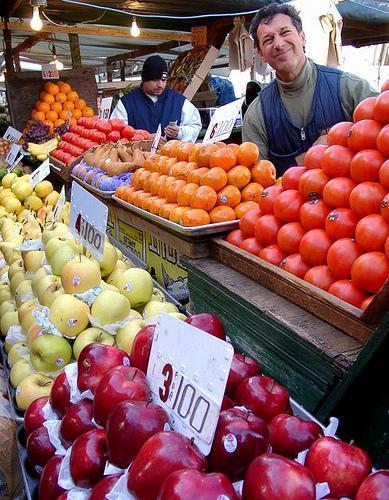How many people are in the picture?
Give a very brief answer. 2. How many red apples can you get for $1.00?
Give a very brief answer. 3. 